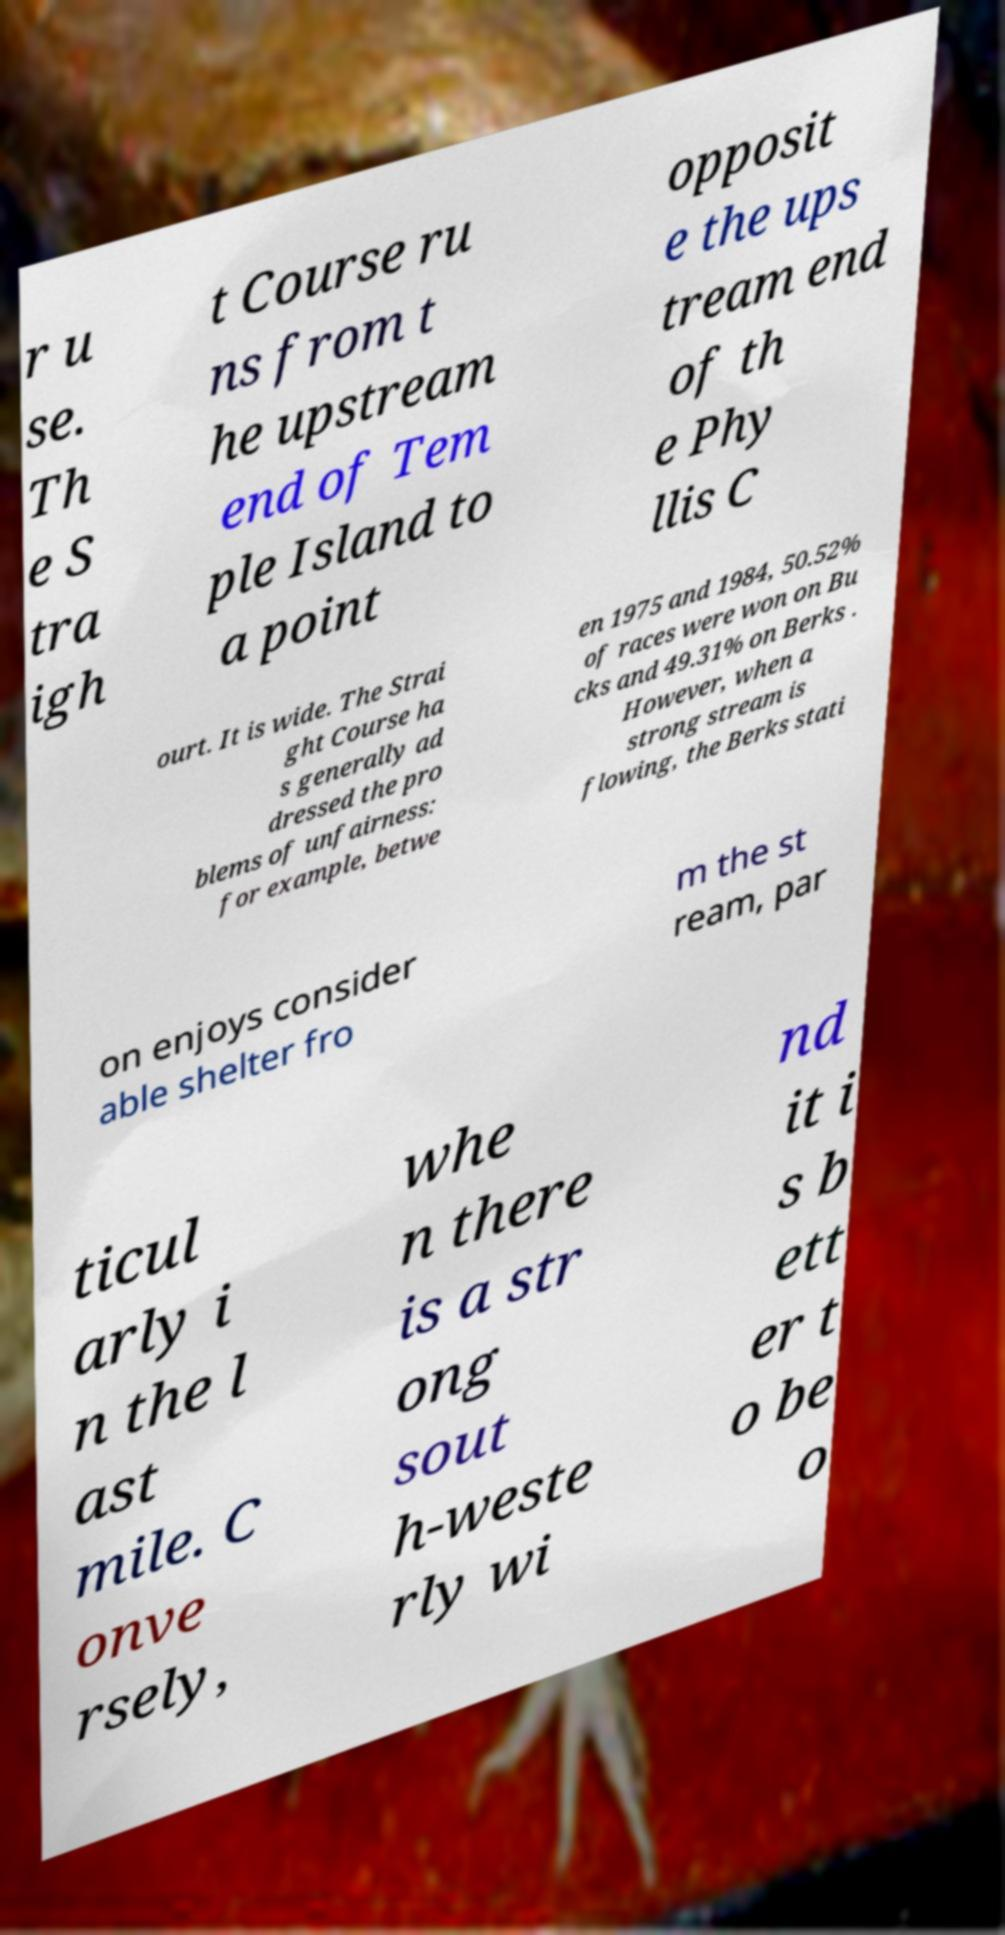Please identify and transcribe the text found in this image. r u se. Th e S tra igh t Course ru ns from t he upstream end of Tem ple Island to a point opposit e the ups tream end of th e Phy llis C ourt. It is wide. The Strai ght Course ha s generally ad dressed the pro blems of unfairness: for example, betwe en 1975 and 1984, 50.52% of races were won on Bu cks and 49.31% on Berks . However, when a strong stream is flowing, the Berks stati on enjoys consider able shelter fro m the st ream, par ticul arly i n the l ast mile. C onve rsely, whe n there is a str ong sout h-weste rly wi nd it i s b ett er t o be o 